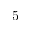<formula> <loc_0><loc_0><loc_500><loc_500>5</formula> 